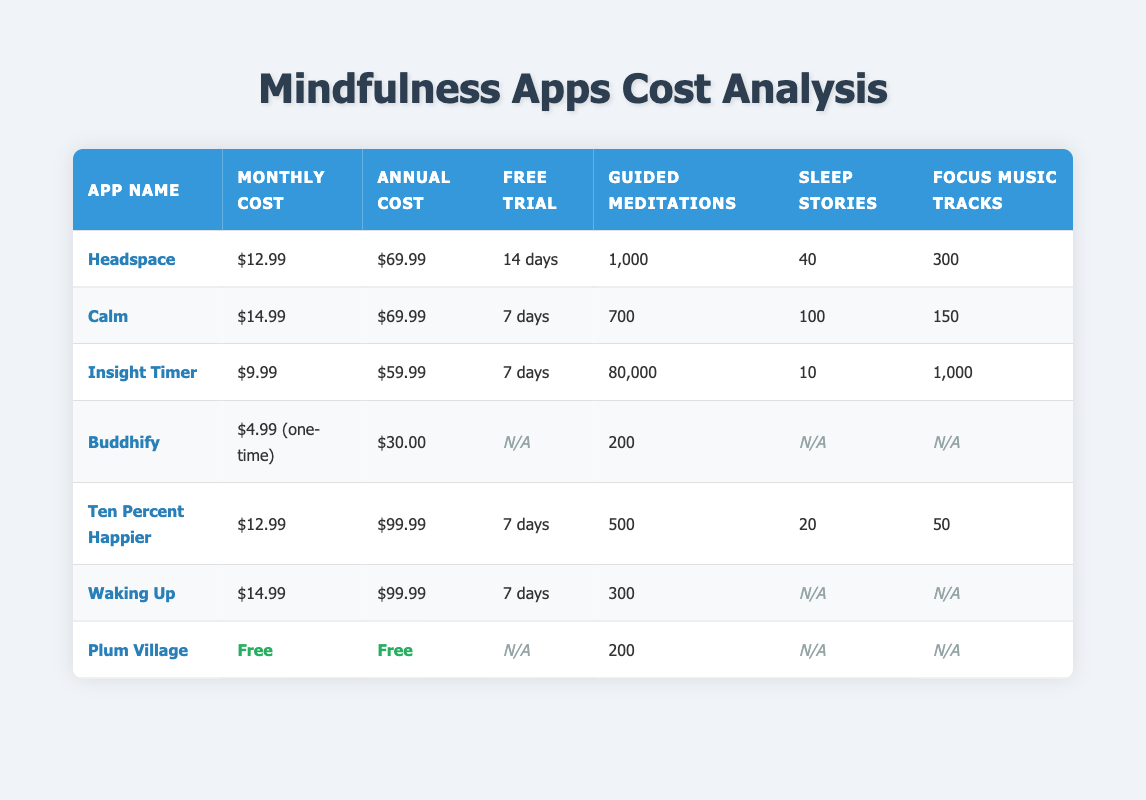What is the monthly cost of Calm? The table shows that the monthly cost of Calm is directly listed under the "Monthly Cost" column. It states the amount as $14.99.
Answer: $14.99 Which app offers the most guided meditations? By comparing the "Guided Meditations" column for each app, Insight Timer has 80,000 guided meditations, which is significantly higher than any other app listed.
Answer: Insight Timer Is there a free trial available for Headspace? The "Free Trial" column for Headspace indicates a 14-day free trial is offered. Thus, the answer is yes.
Answer: Yes What is the total annual cost of the two most expensive apps? Looking at the "Annual Cost" column, Waking Up costs $99.99 and Ten Percent Happier costs $99.99. The total annual cost is calculated as $99.99 + $99.99 = $199.98.
Answer: $199.98 Is Plum Village free? The table states that both the monthly and annual costs for Plum Village are marked as "Free," confirming there is no cost associated with it.
Answer: Yes What is the average monthly cost of the apps that have a monthly subscription? The monthly costs from the relevant apps are Headspace ($12.99), Calm ($14.99), Insight Timer ($9.99), Ten Percent Happier ($12.99), and Waking Up ($14.99). Summing these: 12.99 + 14.99 + 9.99 + 12.99 + 14.99 = 65.95. There are 5 apps, so the average is calculated as 65.95 / 5 = 13.19.
Answer: $13.19 How many sleep stories does Buddhify offer? The "Sleep Stories" column for Buddhify indicates that it offers 0 sleep stories.
Answer: 0 Which app has the most focus music tracks? In the "Focus Music Tracks" column, Insight Timer has 1,000 tracks, which is more than all other apps listed.
Answer: Insight Timer 